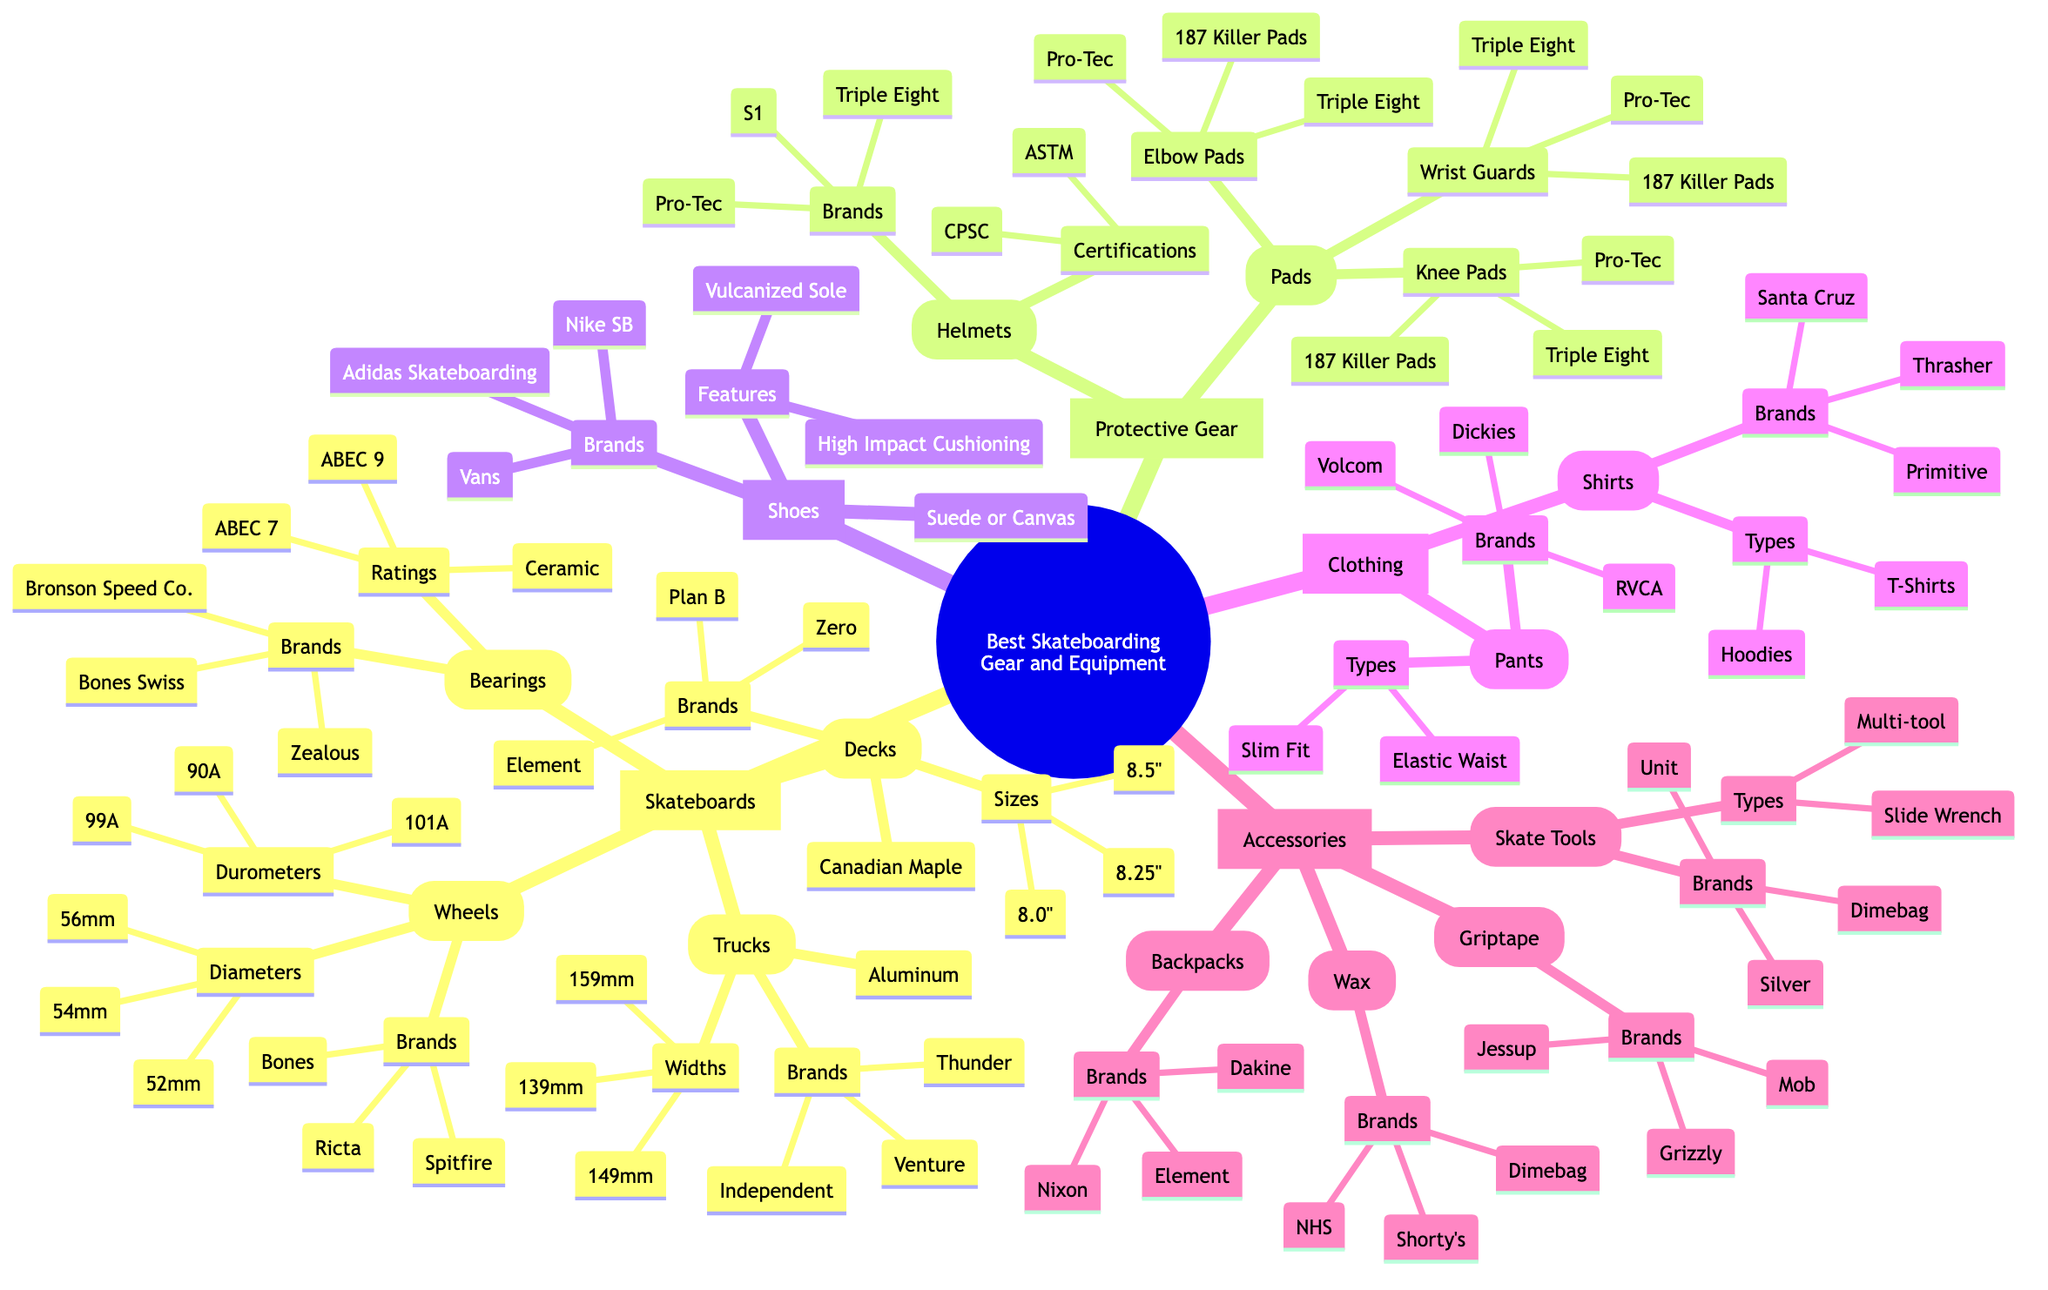What material are the skateboards decks made of? The diagram specifies that the material of the skateboard decks is Canadian Maple, which is listed directly under the Decks category.
Answer: Canadian Maple How many brands are listed for skateboard trucks? The diagram shows three brands listed under the Trucks category: Independent, Thunder, and Venture. Therefore, there are three distinct brands for skateboard trucks.
Answer: 3 Which type of protective gear has certifications? Under the Protective Gear category, the Helmets sub-category includes Certifications, which is not listed under other types of protective gear like Pads. This indicates that helmets specifically have certifications mentioned in the diagram.
Answer: Helmets What are the diameters of the skateboard wheels? The diagram details the Diameters under the Wheels category, listing three specific sizes: 52mm, 54mm, and 56mm.
Answer: 52mm, 54mm, 56mm What brand of shoes features vulcanized soles? The Shoes category mentions several brands, but specifically, it points out that Vans, Nike SB, and Adidas Skateboarding are notable brands and all feature vulcanized soles. Since the question asks for brands that highlight this feature, we can identify one brand: Vans is particularly prominent for this feature.
Answer: Vans What types of shirts are introduced in the clothing section? In the Clothing category, the Shirts section lists two types: T-Shirts and Hoodies. Therefore, answering this requires identifying both types under the Shirts.
Answer: T-Shirts, Hoodies Name a type of skate tool mentioned in the accessories. The diagram shows Types listed under the Skate Tools section, specifically mentioning Multi-tool and Slide Wrench. To answer this question, we can simply choose one of them, like Multi-tool, since it's a direct answer found within the diagram.
Answer: Multi-tool How many different sizes are listed for skateboard decks? The Decks sub-category includes three sizes: 8.0 inches, 8.25 inches, and 8.5 inches. Therefore, this requires a count of all the sizes listed for deck sizes in the diagram.
Answer: 3 What is the material used in skateboarding shoes? The Shoes category indicates that the material used for skateboarding shoes is either Suede or Canvas, which is outlined directly in the diagram.
Answer: Suede or Canvas 